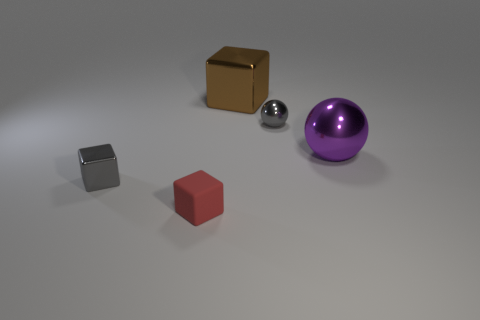Subtract all shiny blocks. How many blocks are left? 1 Subtract all red cubes. How many cubes are left? 2 Subtract 2 blocks. How many blocks are left? 1 Add 2 purple balls. How many objects exist? 7 Subtract all blocks. How many objects are left? 2 Subtract all red cubes. Subtract all green cylinders. How many cubes are left? 2 Subtract all tiny gray metallic cubes. Subtract all large cyan shiny spheres. How many objects are left? 4 Add 1 red cubes. How many red cubes are left? 2 Add 4 tiny gray balls. How many tiny gray balls exist? 5 Subtract 1 gray balls. How many objects are left? 4 